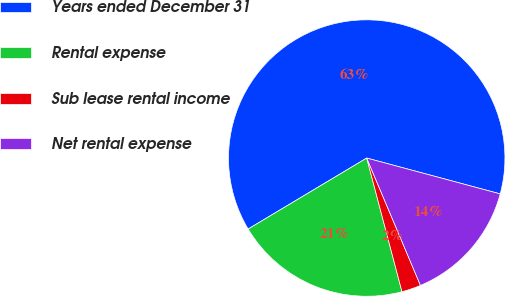<chart> <loc_0><loc_0><loc_500><loc_500><pie_chart><fcel>Years ended December 31<fcel>Rental expense<fcel>Sub lease rental income<fcel>Net rental expense<nl><fcel>62.76%<fcel>20.52%<fcel>2.25%<fcel>14.47%<nl></chart> 